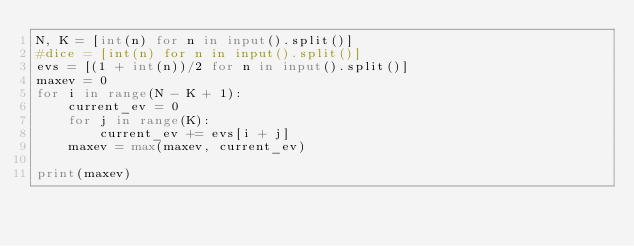Convert code to text. <code><loc_0><loc_0><loc_500><loc_500><_Python_>N, K = [int(n) for n in input().split()]
#dice = [int(n) for n in input().split()]
evs = [(1 + int(n))/2 for n in input().split()]
maxev = 0
for i in range(N - K + 1):
    current_ev = 0
    for j in range(K):
        current_ev += evs[i + j]
    maxev = max(maxev, current_ev)

print(maxev)</code> 